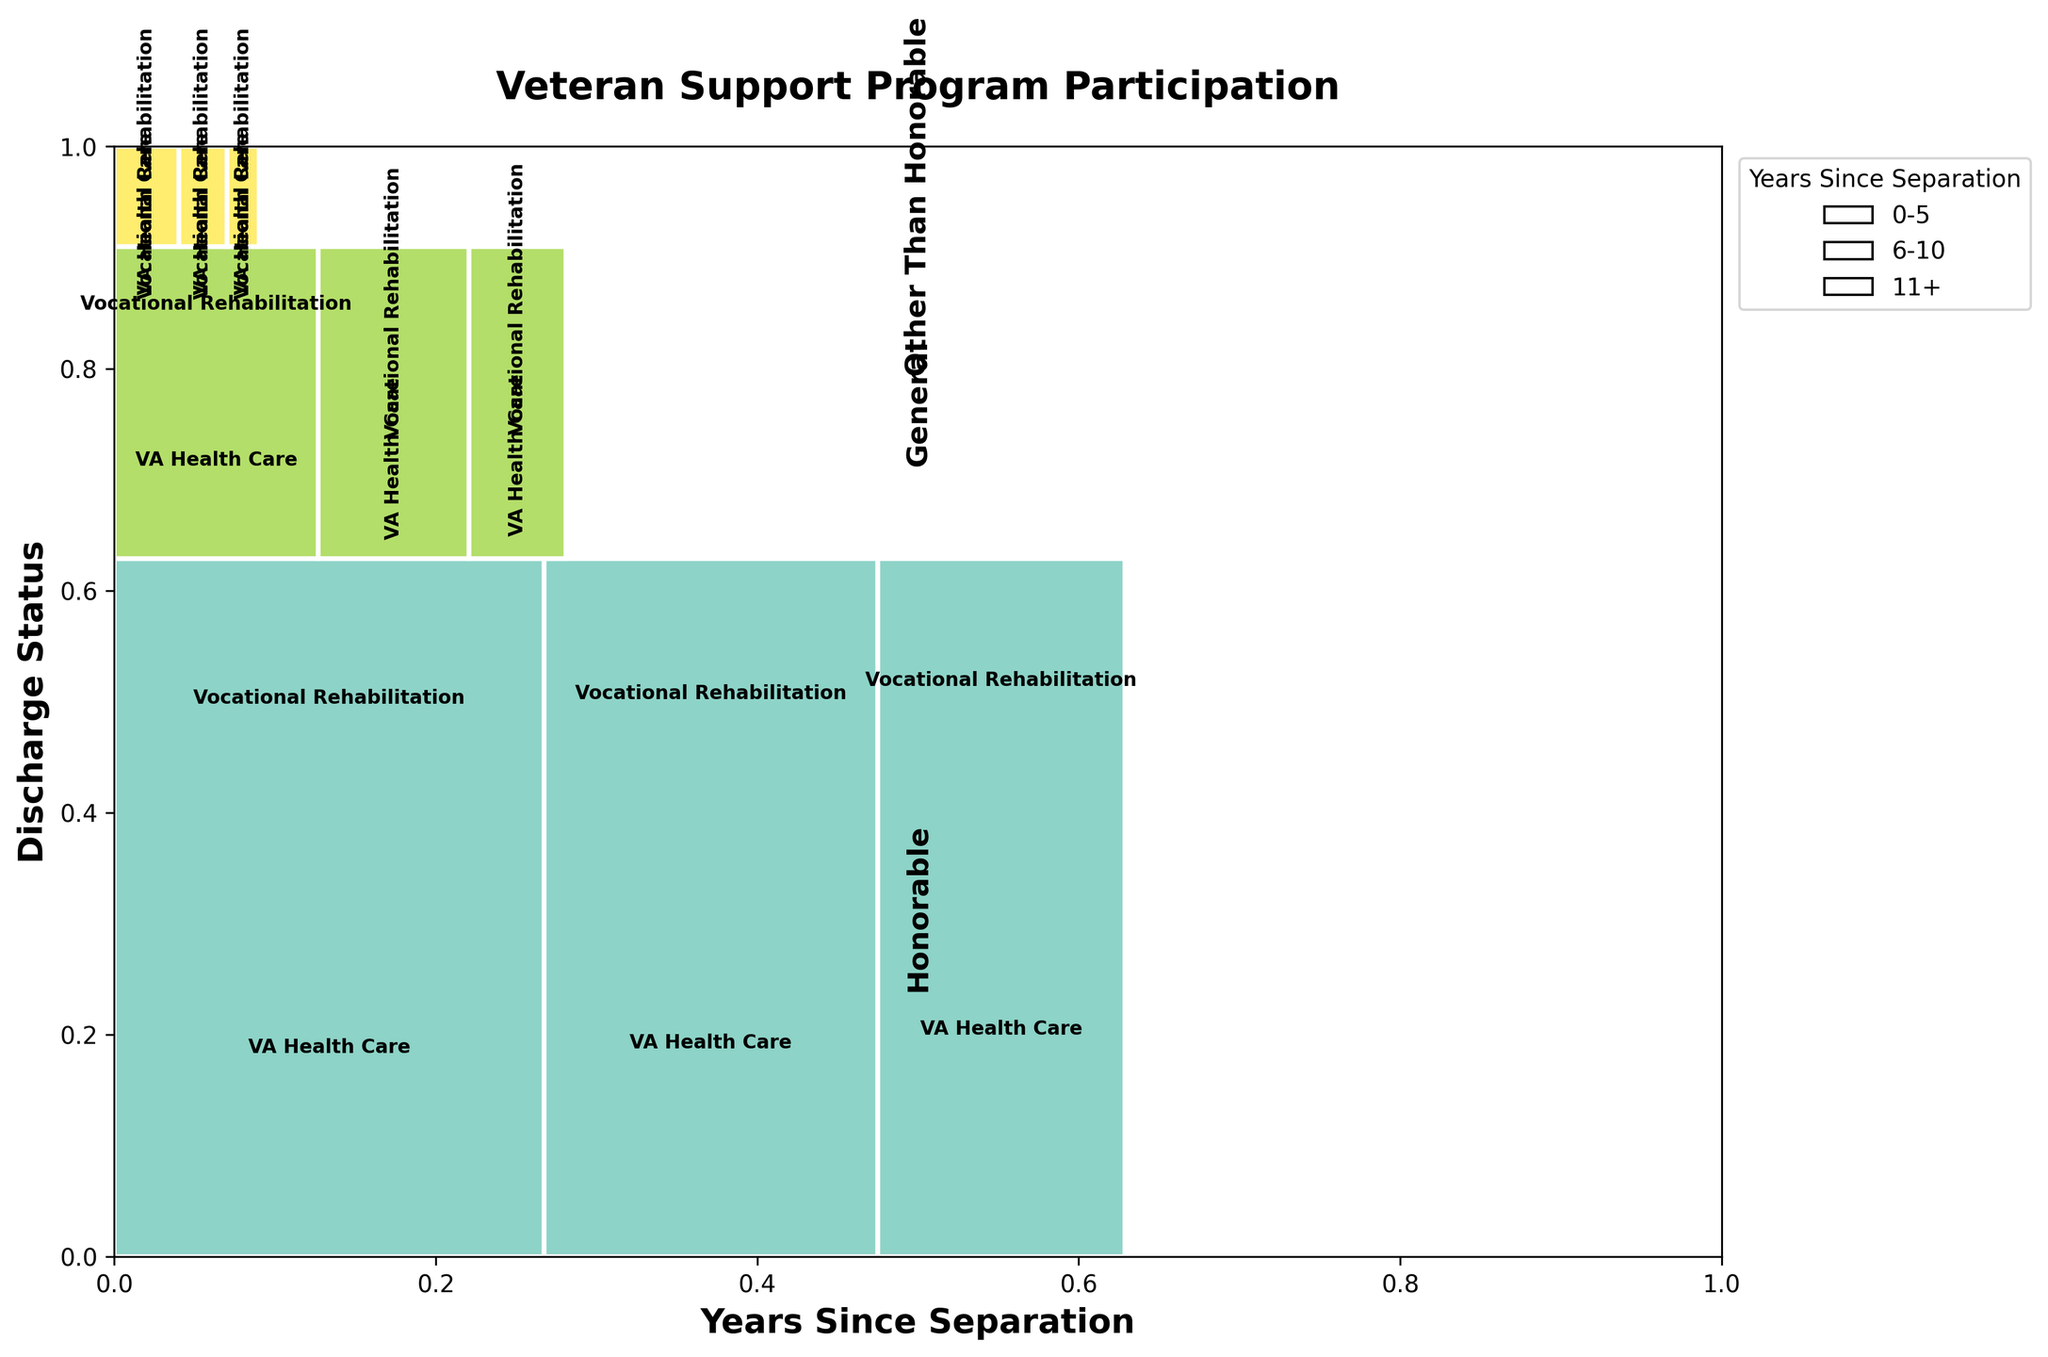What is the title of the plot? The title is usually displayed prominently at the top of the figure. In this case, it should read "Veteran Support Program Participation" as stated in the code.
Answer: Veteran Support Program Participation What are the axes labels in the plot? The X-axis and Y-axis labels are printed along the respective axes in most plots. Here, the X-axis is labeled "Years Since Separation" and the Y-axis is labeled "Discharge Status" based on the code provided.
Answer: Years Since Separation, Discharge Status Which color scheme is used for the discharge statuses in the plot? According to the code, a color scheme from Matplotlib's 'Set3' colormap is used. Different discharge statuses are colored differently, making it easy to distinguish them visually.
Answer: Different colors from the Set3 colormap Which discharge status has the highest overall participation in support programs? To answer this, look at the overall area each discharge status occupies in the plot. Honorable discharge status will have the largest area since their combined participation count is highest.
Answer: Honorable How does participation in Vocational Rehabilitation change across years since separation for General discharge status? Observe the sections labeled "General" and note the size proportions of "Vocational Rehabilitation" across different years. The count reduces as the years since separation increase.
Answer: It decreases Which program has the largest participation in the 0-5 years since separation category? Focus on the width of the sections corresponding to the 0-5 years category for all discharge statuses. "VA Health Care" has the largest proportion in this category, indicated by the wider bars.
Answer: VA Health Care Comparing VA Health Care and Vocational Rehabilitation for Honorable discharge after 11+ years, which has higher participation? Look at the sections for Honorable discharge and 11+ years. The rectangle for VA Health Care is larger compared to Vocational Rehabilitation.
Answer: VA Health Care Summing up all the categories, what is the total participation for General discharge status in VA Health Care? Add the counts of General discharge status in VA Health Care across all years: 600 (0-5) + 450 (6-10) + 300 (11+), resulting in 1350.
Answer: 1350 Between General and Other Than Honorable discharge statuses, which has a higher participation in Vocational Rehabilitation for the 6-10 years category? Compare the portions of the two discharge statuses under the 6-10 years category for Vocational Rehabilitation. General has a larger section, meaning a higher count.
Answer: General 